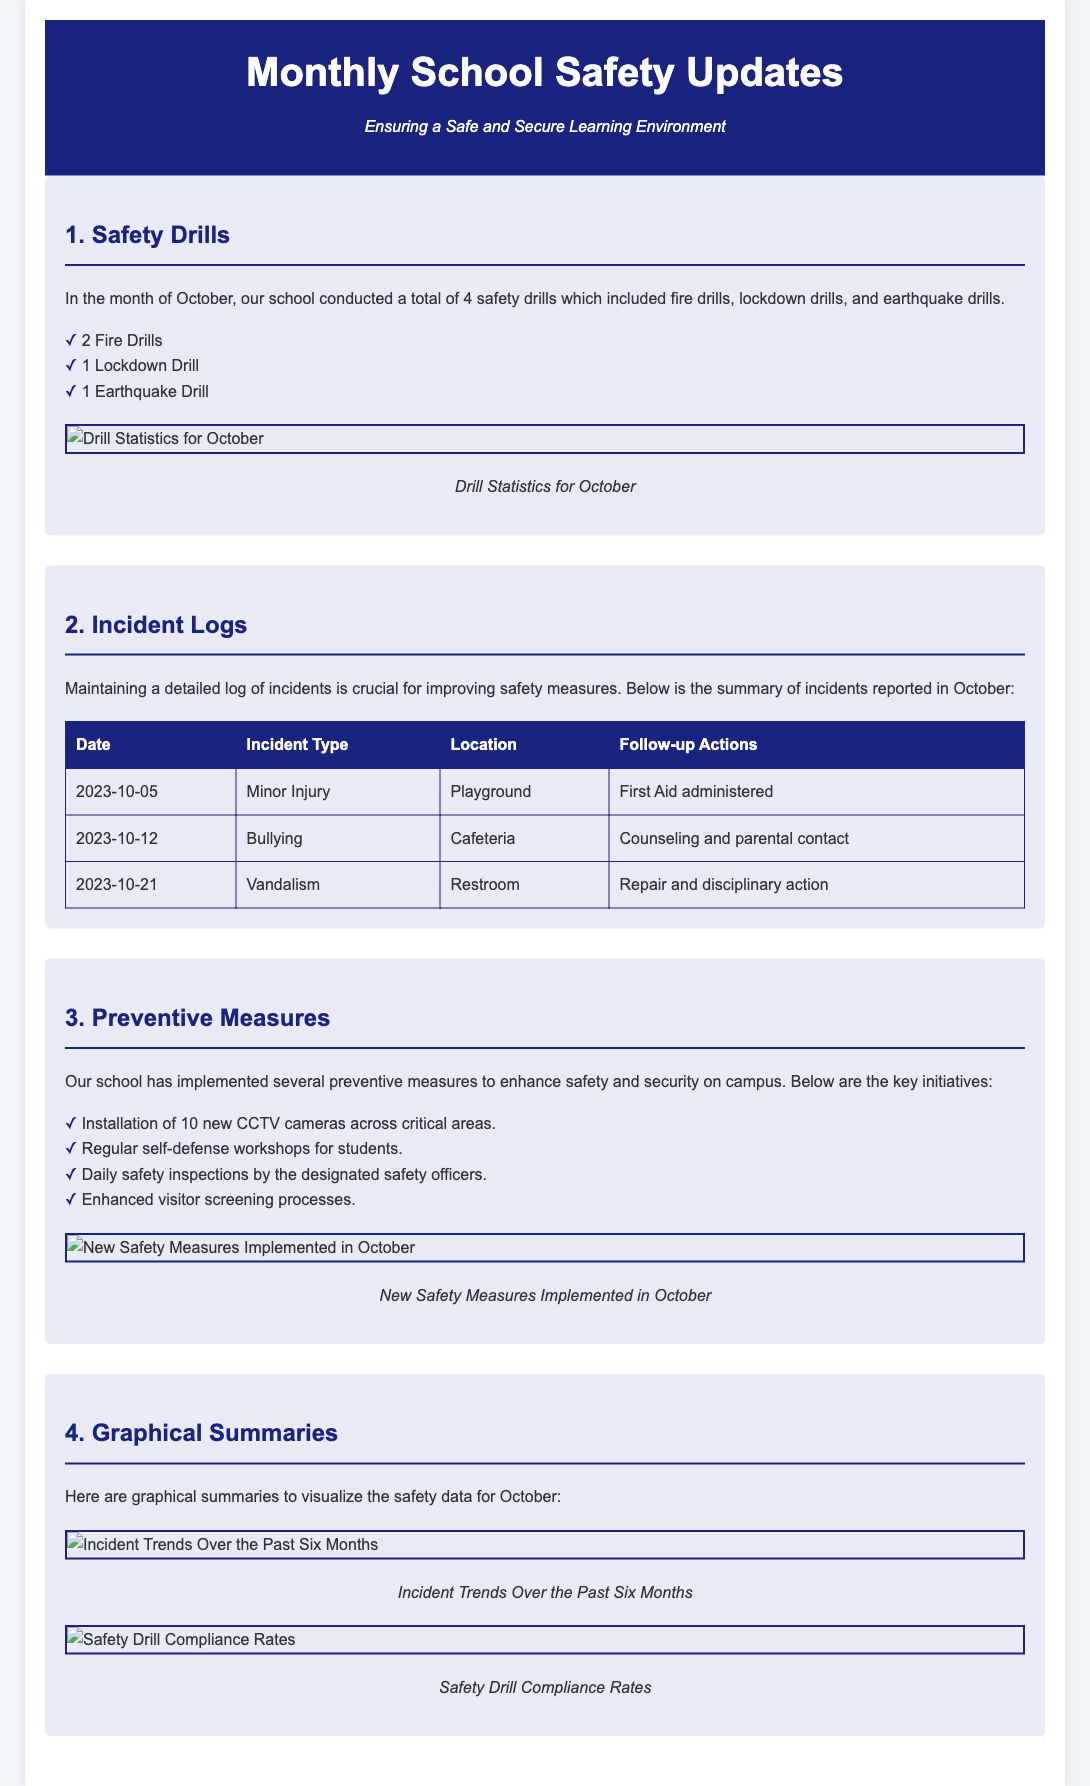what is the total number of safety drills conducted in October? The document states that the school conducted a total of 4 safety drills in October.
Answer: 4 how many fire drills were conducted? According to the report, 2 fire drills were part of the total safety drills conducted.
Answer: 2 what incident type was reported on October 12? The incident reported on this date was categorized as "Bullying."
Answer: Bullying what location had a minor injury incident? The minor injury incident occurred at the Playground.
Answer: Playground what preventive measure involves regular workshops? The document mentions "regular self-defense workshops for students" as a preventive measure.
Answer: self-defense workshops which month does the graphical summary represent? The graphical summaries visualized the safety data specifically for the month of October.
Answer: October how many new CCTV cameras were installed? The report states that 10 new CCTV cameras were installed across critical areas.
Answer: 10 what action was taken for the vandalism incident? The follow-up action for the vandalism incident included repair and disciplinary action.
Answer: Repair and disciplinary action what is the significance of maintaining incident logs? The document emphasizes that maintaining a detailed log of incidents is crucial for improving safety measures.
Answer: Improving safety measures 